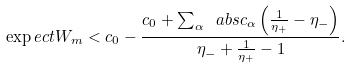<formula> <loc_0><loc_0><loc_500><loc_500>\exp e c t { W } _ { m } < c _ { 0 } - \frac { c _ { 0 } + \sum _ { \alpha } \ a b s { c _ { \alpha } } \left ( \frac { 1 } { \eta _ { + } } - \eta _ { - } \right ) } { \eta _ { - } + \frac { 1 } { \eta _ { + } } - 1 } .</formula> 